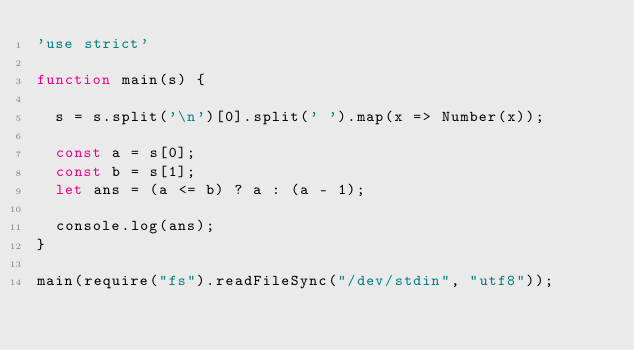<code> <loc_0><loc_0><loc_500><loc_500><_JavaScript_>'use strict'

function main(s) {

  s = s.split('\n')[0].split(' ').map(x => Number(x));

  const a = s[0];
  const b = s[1];
  let ans = (a <= b) ? a : (a - 1);

  console.log(ans);
}

main(require("fs").readFileSync("/dev/stdin", "utf8"));
</code> 